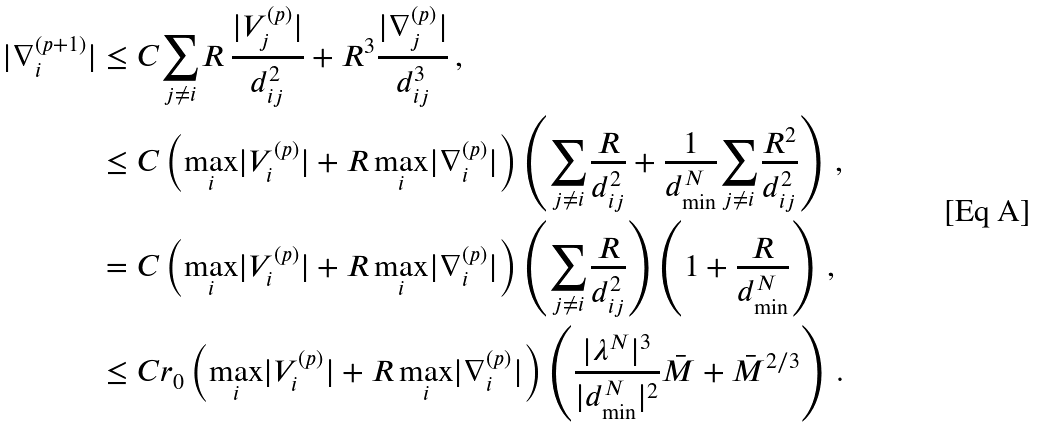<formula> <loc_0><loc_0><loc_500><loc_500>| \nabla _ { i } ^ { ( p + 1 ) } | & \leq C \underset { j \neq i } { \sum } R \, \frac { | V _ { j } ^ { ( p ) } | } { d _ { i j } ^ { 2 } } + R ^ { 3 } \frac { | \nabla _ { j } ^ { ( p ) } | } { d _ { i j } ^ { 3 } } \, , \\ & \leq C \left ( \underset { i } { \max } | V _ { i } ^ { ( p ) } | + R \, \underset { i } { \max } | \nabla _ { i } ^ { ( p ) } | \right ) \left ( \underset { j \neq i } { \sum } \frac { R } { d _ { i j } ^ { 2 } } + \frac { 1 } { d _ { \min } ^ { N } } \underset { j \neq i } { \sum } \frac { R ^ { 2 } } { d _ { i j } ^ { 2 } } \right ) \, , \\ & = C \left ( \underset { i } { \max } | V _ { i } ^ { ( p ) } | + R \, \underset { i } { \max } | \nabla _ { i } ^ { ( p ) } | \right ) \left ( \underset { j \neq i } { \sum } \frac { R } { d _ { i j } ^ { 2 } } \right ) \left ( 1 + \frac { R } { d _ { \min } ^ { N } } \right ) \, , \\ & \leq C r _ { 0 } \left ( \underset { i } { \max } | V _ { i } ^ { ( p ) } | + R \, \underset { i } { \max } | \nabla _ { i } ^ { ( p ) } | \right ) \left ( \frac { | \lambda ^ { N } | ^ { 3 } } { | d _ { \min } ^ { N } | ^ { 2 } } \bar { M } + \bar { M } ^ { 2 / 3 } \right ) \, .</formula> 